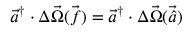<formula> <loc_0><loc_0><loc_500><loc_500>\ V e c { a } ^ { \dagger } \cdot \Delta \vec { \Omega } { \ V e c { ( f ) } } = \ V e c { a } ^ { \dagger } \cdot \Delta \vec { \Omega } { \ V e c { ( \hat { a } ) } }</formula> 